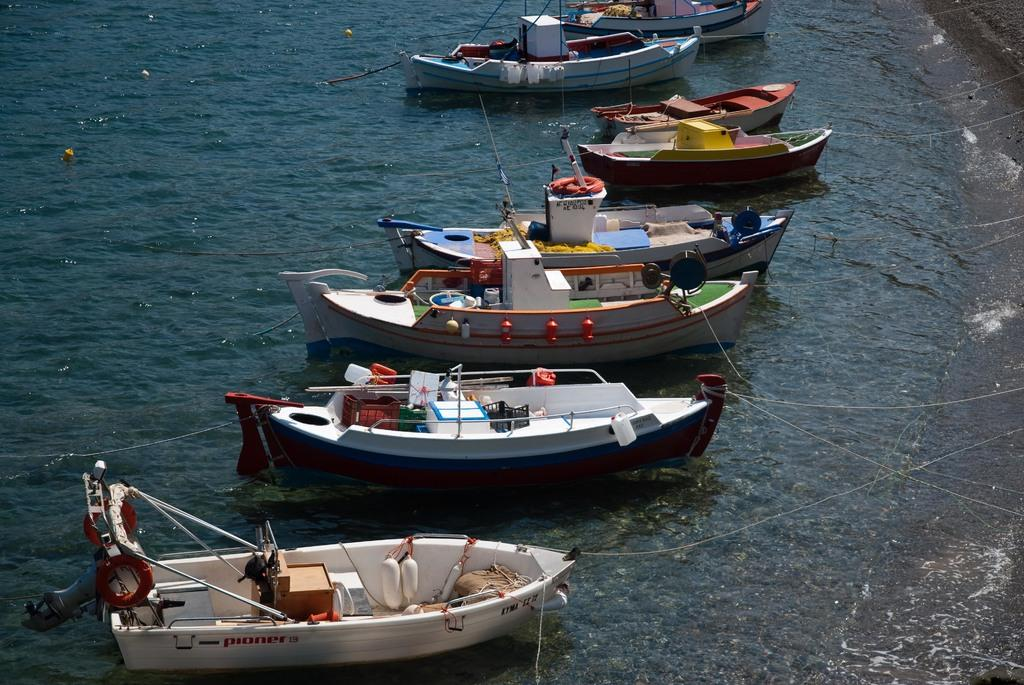What type of vehicles can be seen in the image? There are boats in the image. What colors are the boats? The boats are white, red, green, and blue in color. Where are the boats located in the image? The boats are on the surface of the water. How are the boats secured in the image? The boats are tied to the shore with ropes. What type of business is being conducted in the image? There is no indication of any business activity in the image; it primarily features boats on the water. 